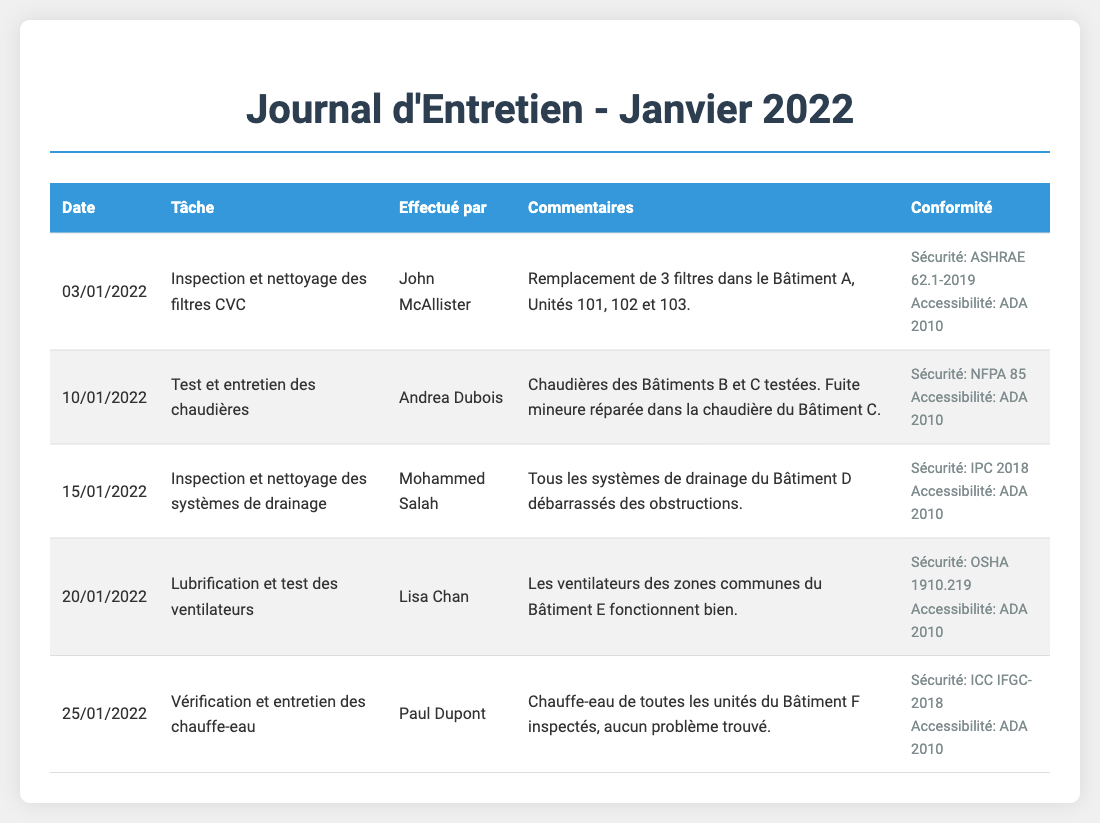What is the date of the first task performed? The first task occurred on January 3, 2022, as indicated in the log.
Answer: 03/01/2022 Who performed the inspection and cleaning of the HVAC filters? The log lists John McAllister as the individual responsible for this task.
Answer: John McAllister How many filters were replaced in Building A? The log specifies that three filters were replaced in Units 101, 102, and 103 of Building A.
Answer: 3 What was repaired in Building C during the boiler maintenance? According to the log, a minor leak was repaired in the boiler of Building C.
Answer: Fuite mineure Which standard is referenced for drain system inspection? The log mentions the IPC 2018 standard for the safety compliance of drainage systems.
Answer: IPC 2018 What was the outcome of the water heater inspection in Building F? The log notes that no problems were found during the inspection of all water heaters in Building F.
Answer: Aucun problème trouvé 